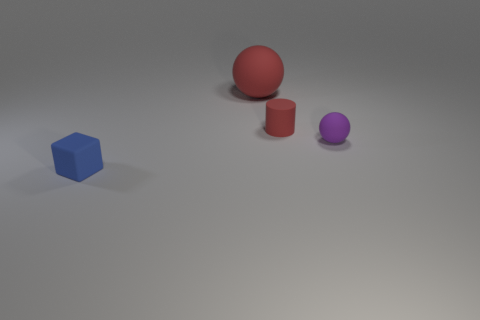Add 4 cylinders. How many objects exist? 8 Subtract all cylinders. How many objects are left? 3 Subtract all gray matte blocks. Subtract all tiny things. How many objects are left? 1 Add 3 tiny rubber cylinders. How many tiny rubber cylinders are left? 4 Add 4 small purple rubber spheres. How many small purple rubber spheres exist? 5 Subtract 0 cyan cylinders. How many objects are left? 4 